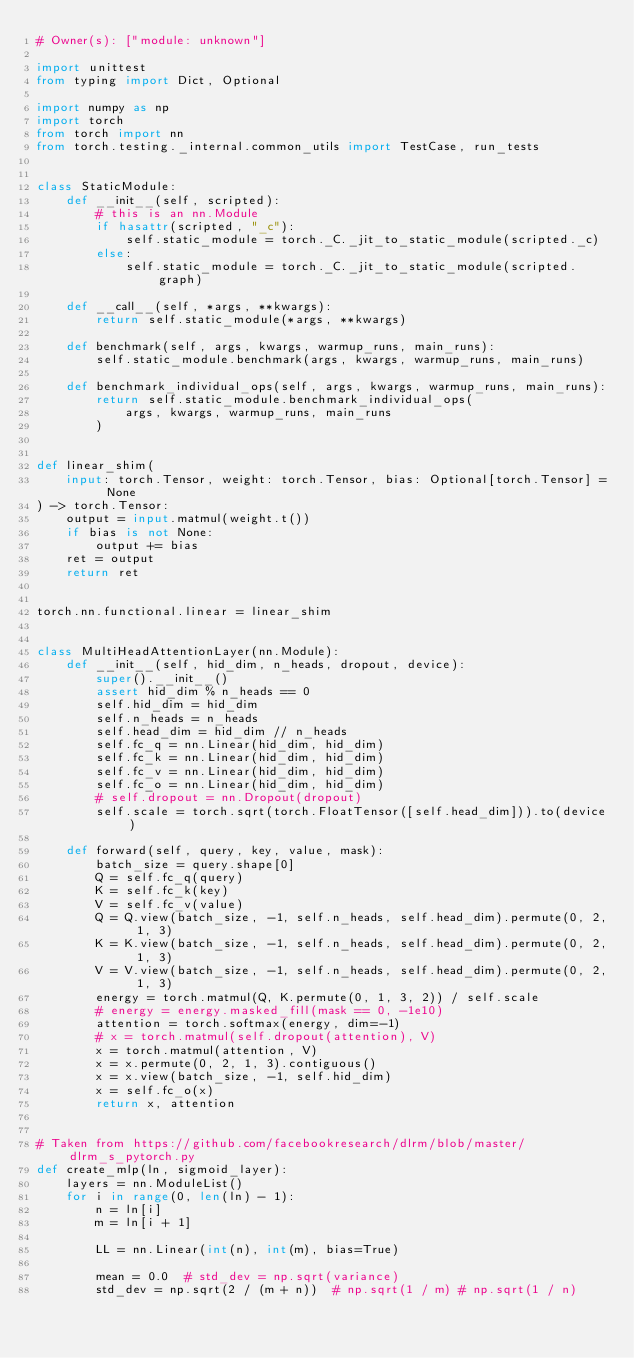<code> <loc_0><loc_0><loc_500><loc_500><_Python_># Owner(s): ["module: unknown"]

import unittest
from typing import Dict, Optional

import numpy as np
import torch
from torch import nn
from torch.testing._internal.common_utils import TestCase, run_tests


class StaticModule:
    def __init__(self, scripted):
        # this is an nn.Module
        if hasattr(scripted, "_c"):
            self.static_module = torch._C._jit_to_static_module(scripted._c)
        else:
            self.static_module = torch._C._jit_to_static_module(scripted.graph)

    def __call__(self, *args, **kwargs):
        return self.static_module(*args, **kwargs)

    def benchmark(self, args, kwargs, warmup_runs, main_runs):
        self.static_module.benchmark(args, kwargs, warmup_runs, main_runs)

    def benchmark_individual_ops(self, args, kwargs, warmup_runs, main_runs):
        return self.static_module.benchmark_individual_ops(
            args, kwargs, warmup_runs, main_runs
        )


def linear_shim(
    input: torch.Tensor, weight: torch.Tensor, bias: Optional[torch.Tensor] = None
) -> torch.Tensor:
    output = input.matmul(weight.t())
    if bias is not None:
        output += bias
    ret = output
    return ret


torch.nn.functional.linear = linear_shim


class MultiHeadAttentionLayer(nn.Module):
    def __init__(self, hid_dim, n_heads, dropout, device):
        super().__init__()
        assert hid_dim % n_heads == 0
        self.hid_dim = hid_dim
        self.n_heads = n_heads
        self.head_dim = hid_dim // n_heads
        self.fc_q = nn.Linear(hid_dim, hid_dim)
        self.fc_k = nn.Linear(hid_dim, hid_dim)
        self.fc_v = nn.Linear(hid_dim, hid_dim)
        self.fc_o = nn.Linear(hid_dim, hid_dim)
        # self.dropout = nn.Dropout(dropout)
        self.scale = torch.sqrt(torch.FloatTensor([self.head_dim])).to(device)

    def forward(self, query, key, value, mask):
        batch_size = query.shape[0]
        Q = self.fc_q(query)
        K = self.fc_k(key)
        V = self.fc_v(value)
        Q = Q.view(batch_size, -1, self.n_heads, self.head_dim).permute(0, 2, 1, 3)
        K = K.view(batch_size, -1, self.n_heads, self.head_dim).permute(0, 2, 1, 3)
        V = V.view(batch_size, -1, self.n_heads, self.head_dim).permute(0, 2, 1, 3)
        energy = torch.matmul(Q, K.permute(0, 1, 3, 2)) / self.scale
        # energy = energy.masked_fill(mask == 0, -1e10)
        attention = torch.softmax(energy, dim=-1)
        # x = torch.matmul(self.dropout(attention), V)
        x = torch.matmul(attention, V)
        x = x.permute(0, 2, 1, 3).contiguous()
        x = x.view(batch_size, -1, self.hid_dim)
        x = self.fc_o(x)
        return x, attention


# Taken from https://github.com/facebookresearch/dlrm/blob/master/dlrm_s_pytorch.py
def create_mlp(ln, sigmoid_layer):
    layers = nn.ModuleList()
    for i in range(0, len(ln) - 1):
        n = ln[i]
        m = ln[i + 1]

        LL = nn.Linear(int(n), int(m), bias=True)

        mean = 0.0  # std_dev = np.sqrt(variance)
        std_dev = np.sqrt(2 / (m + n))  # np.sqrt(1 / m) # np.sqrt(1 / n)</code> 